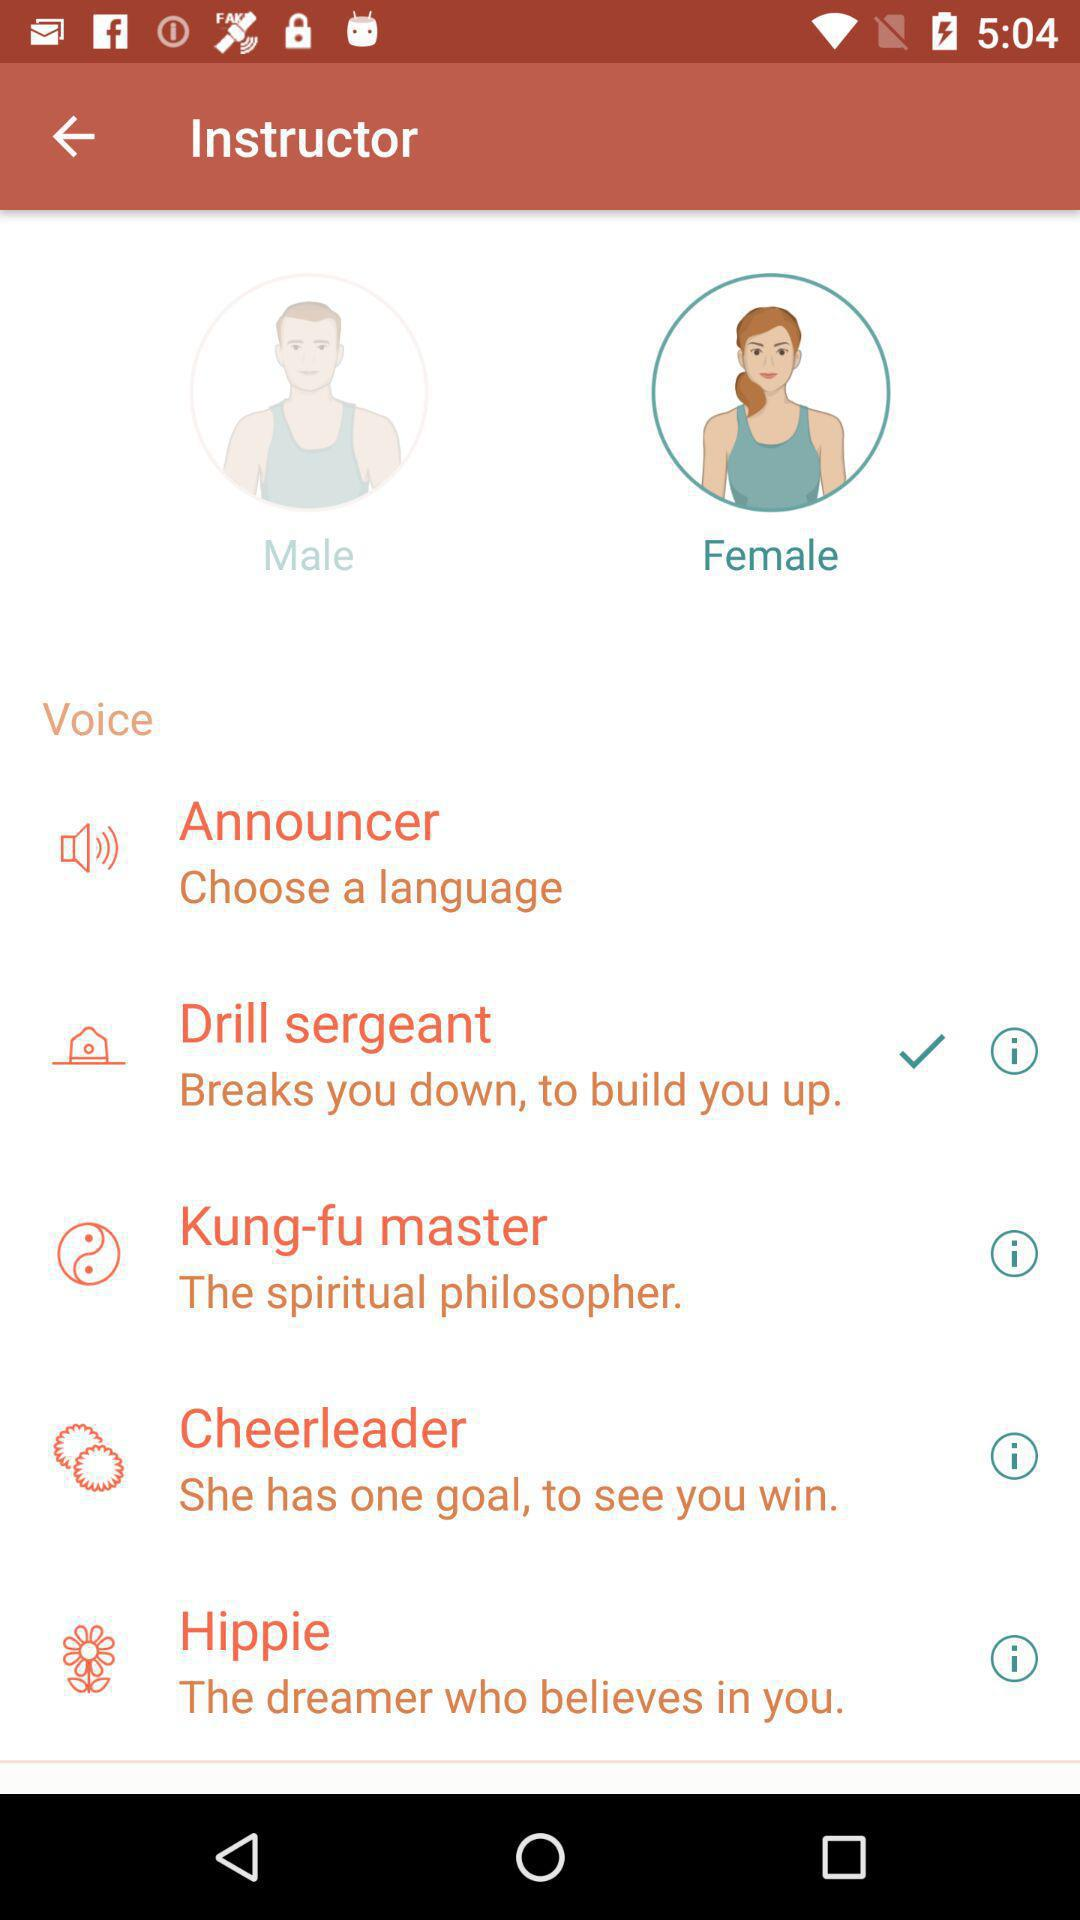Which voice is selected? The selected voice is "Drill sergeant". 